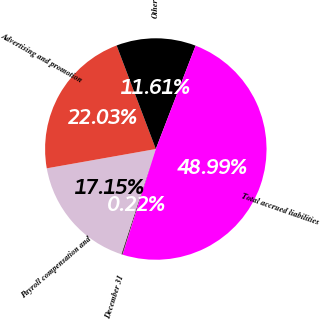Convert chart. <chart><loc_0><loc_0><loc_500><loc_500><pie_chart><fcel>December 31<fcel>Payroll compensation and<fcel>Advertising and promotion<fcel>Other<fcel>Total accrued liabilities<nl><fcel>0.22%<fcel>17.15%<fcel>22.03%<fcel>11.61%<fcel>48.99%<nl></chart> 